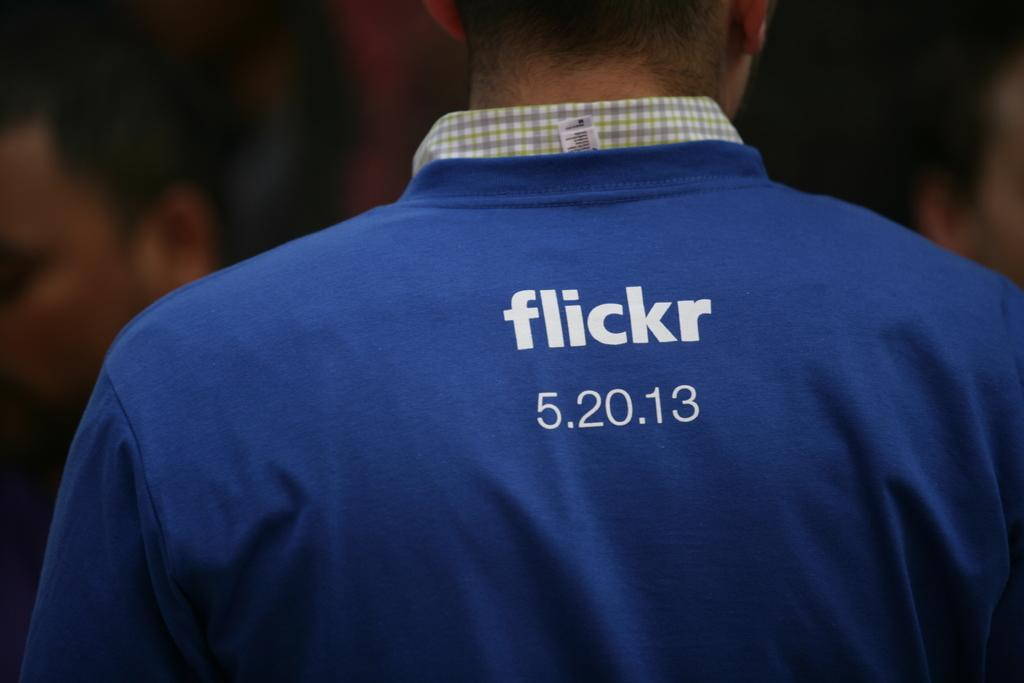<image>
Give a short and clear explanation of the subsequent image. a person wearing a blue shirt with the text flicker and 5.20.13 on it 